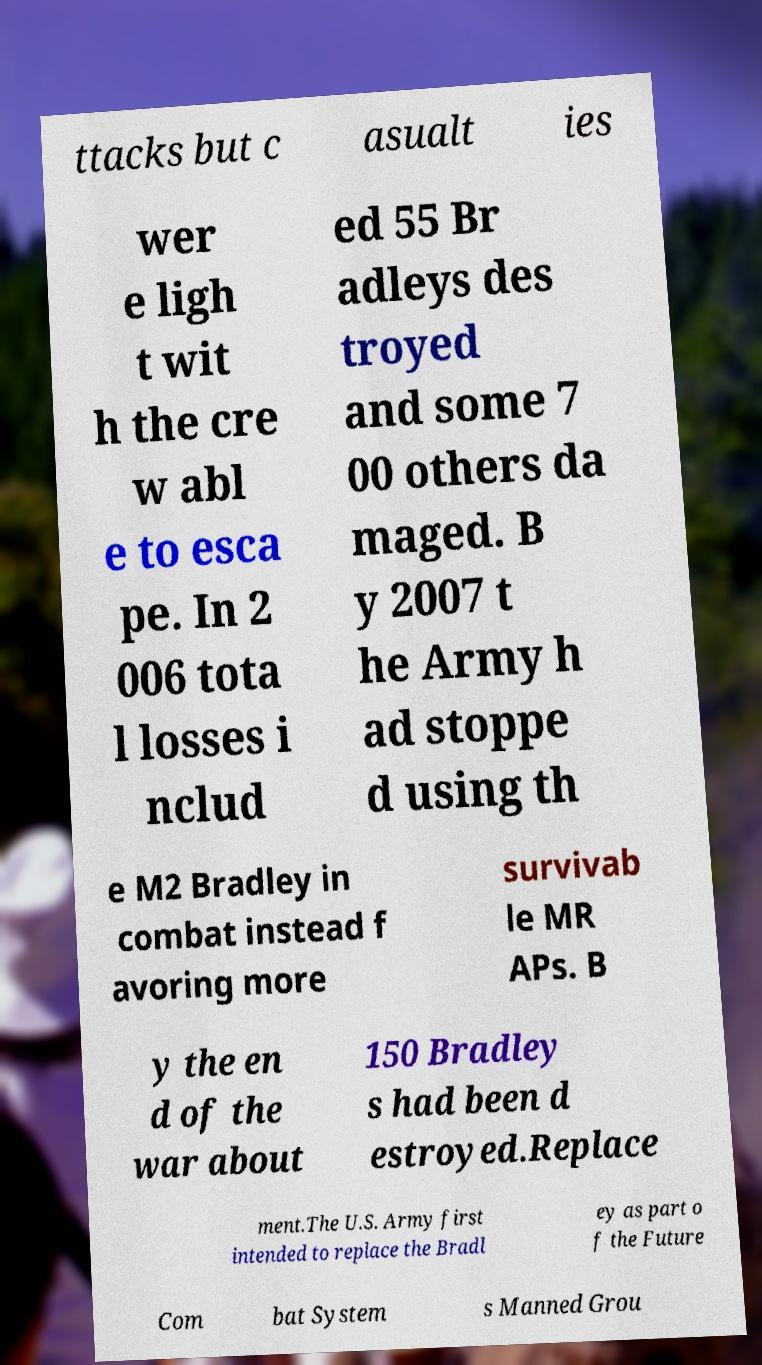Please identify and transcribe the text found in this image. ttacks but c asualt ies wer e ligh t wit h the cre w abl e to esca pe. In 2 006 tota l losses i nclud ed 55 Br adleys des troyed and some 7 00 others da maged. B y 2007 t he Army h ad stoppe d using th e M2 Bradley in combat instead f avoring more survivab le MR APs. B y the en d of the war about 150 Bradley s had been d estroyed.Replace ment.The U.S. Army first intended to replace the Bradl ey as part o f the Future Com bat System s Manned Grou 